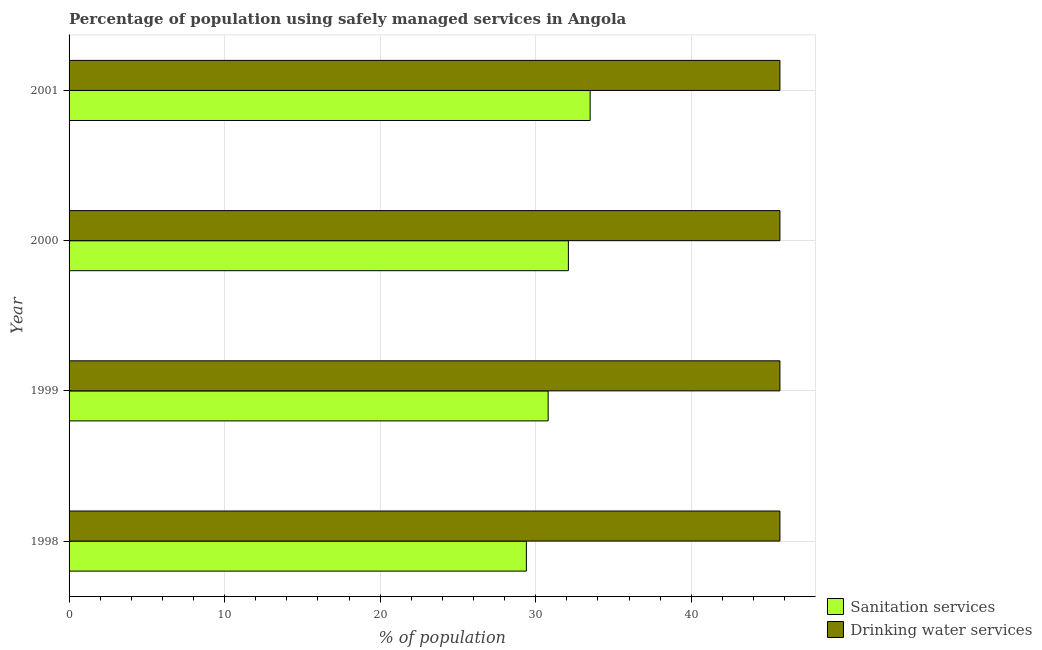How many different coloured bars are there?
Ensure brevity in your answer.  2. Are the number of bars per tick equal to the number of legend labels?
Your answer should be very brief. Yes. Are the number of bars on each tick of the Y-axis equal?
Offer a very short reply. Yes. How many bars are there on the 2nd tick from the top?
Make the answer very short. 2. What is the label of the 4th group of bars from the top?
Your response must be concise. 1998. In how many cases, is the number of bars for a given year not equal to the number of legend labels?
Offer a very short reply. 0. What is the percentage of population who used sanitation services in 1998?
Give a very brief answer. 29.4. Across all years, what is the maximum percentage of population who used sanitation services?
Your answer should be compact. 33.5. Across all years, what is the minimum percentage of population who used drinking water services?
Your response must be concise. 45.7. In which year was the percentage of population who used drinking water services maximum?
Your answer should be very brief. 1998. In which year was the percentage of population who used sanitation services minimum?
Make the answer very short. 1998. What is the total percentage of population who used sanitation services in the graph?
Give a very brief answer. 125.8. What is the difference between the percentage of population who used sanitation services in 1998 and that in 1999?
Give a very brief answer. -1.4. What is the difference between the percentage of population who used drinking water services in 2000 and the percentage of population who used sanitation services in 2001?
Provide a succinct answer. 12.2. What is the average percentage of population who used drinking water services per year?
Your answer should be very brief. 45.7. In the year 2001, what is the difference between the percentage of population who used drinking water services and percentage of population who used sanitation services?
Your response must be concise. 12.2. In how many years, is the percentage of population who used sanitation services greater than 32 %?
Offer a very short reply. 2. What is the ratio of the percentage of population who used drinking water services in 2000 to that in 2001?
Provide a short and direct response. 1. Is the difference between the percentage of population who used sanitation services in 1999 and 2000 greater than the difference between the percentage of population who used drinking water services in 1999 and 2000?
Offer a very short reply. No. What is the difference between the highest and the lowest percentage of population who used sanitation services?
Keep it short and to the point. 4.1. Is the sum of the percentage of population who used drinking water services in 1999 and 2001 greater than the maximum percentage of population who used sanitation services across all years?
Offer a very short reply. Yes. What does the 2nd bar from the top in 2000 represents?
Make the answer very short. Sanitation services. What does the 2nd bar from the bottom in 2001 represents?
Provide a short and direct response. Drinking water services. Are all the bars in the graph horizontal?
Ensure brevity in your answer.  Yes. How many years are there in the graph?
Ensure brevity in your answer.  4. Are the values on the major ticks of X-axis written in scientific E-notation?
Offer a very short reply. No. Does the graph contain grids?
Your answer should be very brief. Yes. How many legend labels are there?
Your answer should be very brief. 2. What is the title of the graph?
Your answer should be very brief. Percentage of population using safely managed services in Angola. Does "Commercial service imports" appear as one of the legend labels in the graph?
Make the answer very short. No. What is the label or title of the X-axis?
Keep it short and to the point. % of population. What is the % of population in Sanitation services in 1998?
Provide a succinct answer. 29.4. What is the % of population of Drinking water services in 1998?
Make the answer very short. 45.7. What is the % of population of Sanitation services in 1999?
Ensure brevity in your answer.  30.8. What is the % of population in Drinking water services in 1999?
Keep it short and to the point. 45.7. What is the % of population of Sanitation services in 2000?
Your response must be concise. 32.1. What is the % of population of Drinking water services in 2000?
Give a very brief answer. 45.7. What is the % of population in Sanitation services in 2001?
Provide a short and direct response. 33.5. What is the % of population of Drinking water services in 2001?
Give a very brief answer. 45.7. Across all years, what is the maximum % of population in Sanitation services?
Keep it short and to the point. 33.5. Across all years, what is the maximum % of population of Drinking water services?
Offer a very short reply. 45.7. Across all years, what is the minimum % of population of Sanitation services?
Offer a terse response. 29.4. Across all years, what is the minimum % of population in Drinking water services?
Make the answer very short. 45.7. What is the total % of population in Sanitation services in the graph?
Provide a succinct answer. 125.8. What is the total % of population in Drinking water services in the graph?
Your answer should be compact. 182.8. What is the difference between the % of population in Sanitation services in 1998 and that in 1999?
Provide a short and direct response. -1.4. What is the difference between the % of population in Drinking water services in 1998 and that in 1999?
Your answer should be very brief. 0. What is the difference between the % of population of Sanitation services in 1998 and that in 2001?
Offer a terse response. -4.1. What is the difference between the % of population in Drinking water services in 1998 and that in 2001?
Keep it short and to the point. 0. What is the difference between the % of population in Drinking water services in 1999 and that in 2000?
Your answer should be very brief. 0. What is the difference between the % of population of Sanitation services in 1999 and that in 2001?
Ensure brevity in your answer.  -2.7. What is the difference between the % of population in Sanitation services in 2000 and that in 2001?
Your response must be concise. -1.4. What is the difference between the % of population in Drinking water services in 2000 and that in 2001?
Your response must be concise. 0. What is the difference between the % of population in Sanitation services in 1998 and the % of population in Drinking water services in 1999?
Ensure brevity in your answer.  -16.3. What is the difference between the % of population of Sanitation services in 1998 and the % of population of Drinking water services in 2000?
Provide a succinct answer. -16.3. What is the difference between the % of population in Sanitation services in 1998 and the % of population in Drinking water services in 2001?
Your answer should be compact. -16.3. What is the difference between the % of population of Sanitation services in 1999 and the % of population of Drinking water services in 2000?
Provide a short and direct response. -14.9. What is the difference between the % of population in Sanitation services in 1999 and the % of population in Drinking water services in 2001?
Give a very brief answer. -14.9. What is the average % of population of Sanitation services per year?
Ensure brevity in your answer.  31.45. What is the average % of population of Drinking water services per year?
Your response must be concise. 45.7. In the year 1998, what is the difference between the % of population of Sanitation services and % of population of Drinking water services?
Provide a short and direct response. -16.3. In the year 1999, what is the difference between the % of population of Sanitation services and % of population of Drinking water services?
Provide a succinct answer. -14.9. In the year 2001, what is the difference between the % of population in Sanitation services and % of population in Drinking water services?
Your answer should be very brief. -12.2. What is the ratio of the % of population of Sanitation services in 1998 to that in 1999?
Make the answer very short. 0.95. What is the ratio of the % of population in Sanitation services in 1998 to that in 2000?
Offer a very short reply. 0.92. What is the ratio of the % of population of Sanitation services in 1998 to that in 2001?
Provide a succinct answer. 0.88. What is the ratio of the % of population of Drinking water services in 1998 to that in 2001?
Offer a terse response. 1. What is the ratio of the % of population of Sanitation services in 1999 to that in 2000?
Make the answer very short. 0.96. What is the ratio of the % of population in Sanitation services in 1999 to that in 2001?
Your response must be concise. 0.92. What is the ratio of the % of population of Drinking water services in 1999 to that in 2001?
Your response must be concise. 1. What is the ratio of the % of population in Sanitation services in 2000 to that in 2001?
Your response must be concise. 0.96. What is the ratio of the % of population of Drinking water services in 2000 to that in 2001?
Offer a very short reply. 1. What is the difference between the highest and the second highest % of population in Sanitation services?
Make the answer very short. 1.4. What is the difference between the highest and the second highest % of population in Drinking water services?
Offer a very short reply. 0. 